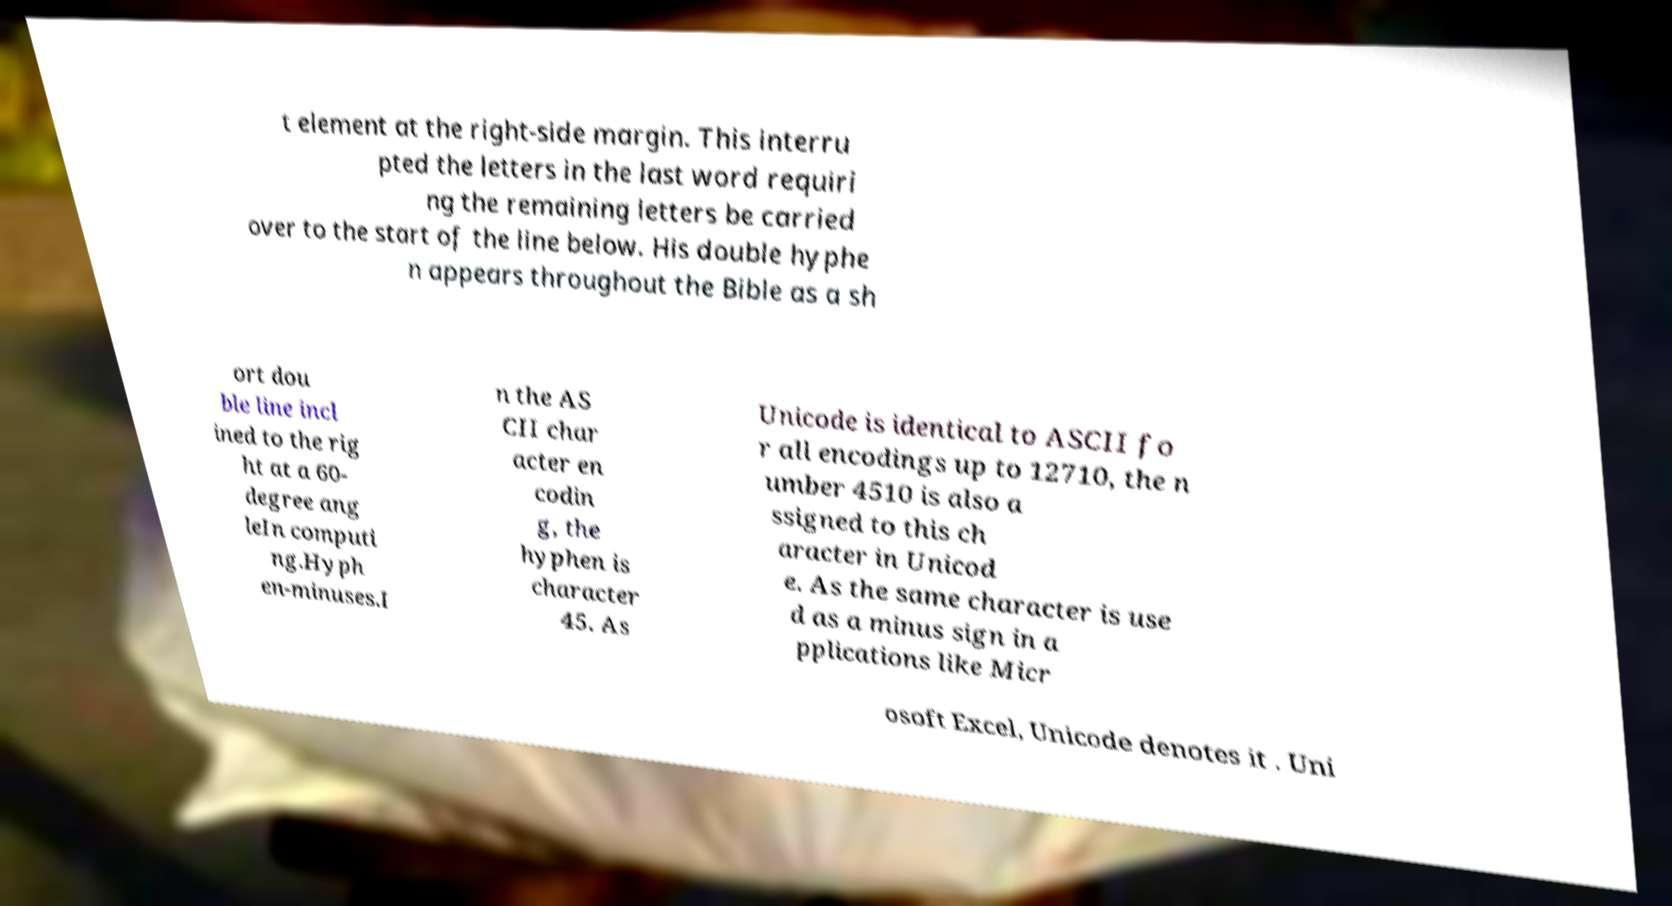What messages or text are displayed in this image? I need them in a readable, typed format. t element at the right-side margin. This interru pted the letters in the last word requiri ng the remaining letters be carried over to the start of the line below. His double hyphe n appears throughout the Bible as a sh ort dou ble line incl ined to the rig ht at a 60- degree ang leIn computi ng.Hyph en-minuses.I n the AS CII char acter en codin g, the hyphen is character 45. As Unicode is identical to ASCII fo r all encodings up to 12710, the n umber 4510 is also a ssigned to this ch aracter in Unicod e. As the same character is use d as a minus sign in a pplications like Micr osoft Excel, Unicode denotes it . Uni 